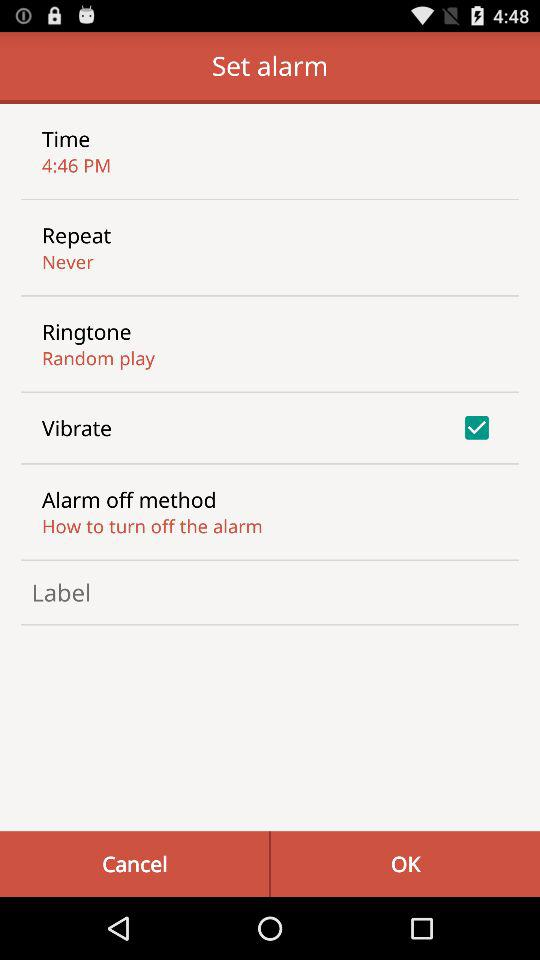For which days of the week is the alarm set?
When the provided information is insufficient, respond with <no answer>. <no answer> 